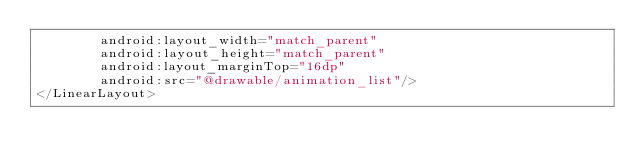<code> <loc_0><loc_0><loc_500><loc_500><_XML_>        android:layout_width="match_parent"
        android:layout_height="match_parent"
        android:layout_marginTop="16dp"
        android:src="@drawable/animation_list"/>
</LinearLayout></code> 